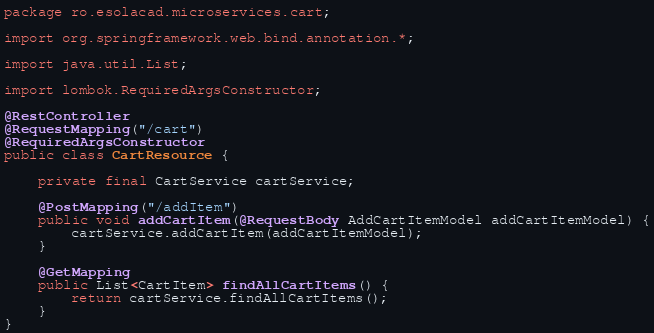Convert code to text. <code><loc_0><loc_0><loc_500><loc_500><_Java_>package ro.esolacad.microservices.cart;

import org.springframework.web.bind.annotation.*;

import java.util.List;

import lombok.RequiredArgsConstructor;

@RestController
@RequestMapping("/cart")
@RequiredArgsConstructor
public class CartResource {

    private final CartService cartService;

    @PostMapping("/addItem")
    public void addCartItem(@RequestBody AddCartItemModel addCartItemModel) {
        cartService.addCartItem(addCartItemModel);
    }

    @GetMapping
    public List<CartItem> findAllCartItems() {
        return cartService.findAllCartItems();
    }
}
</code> 